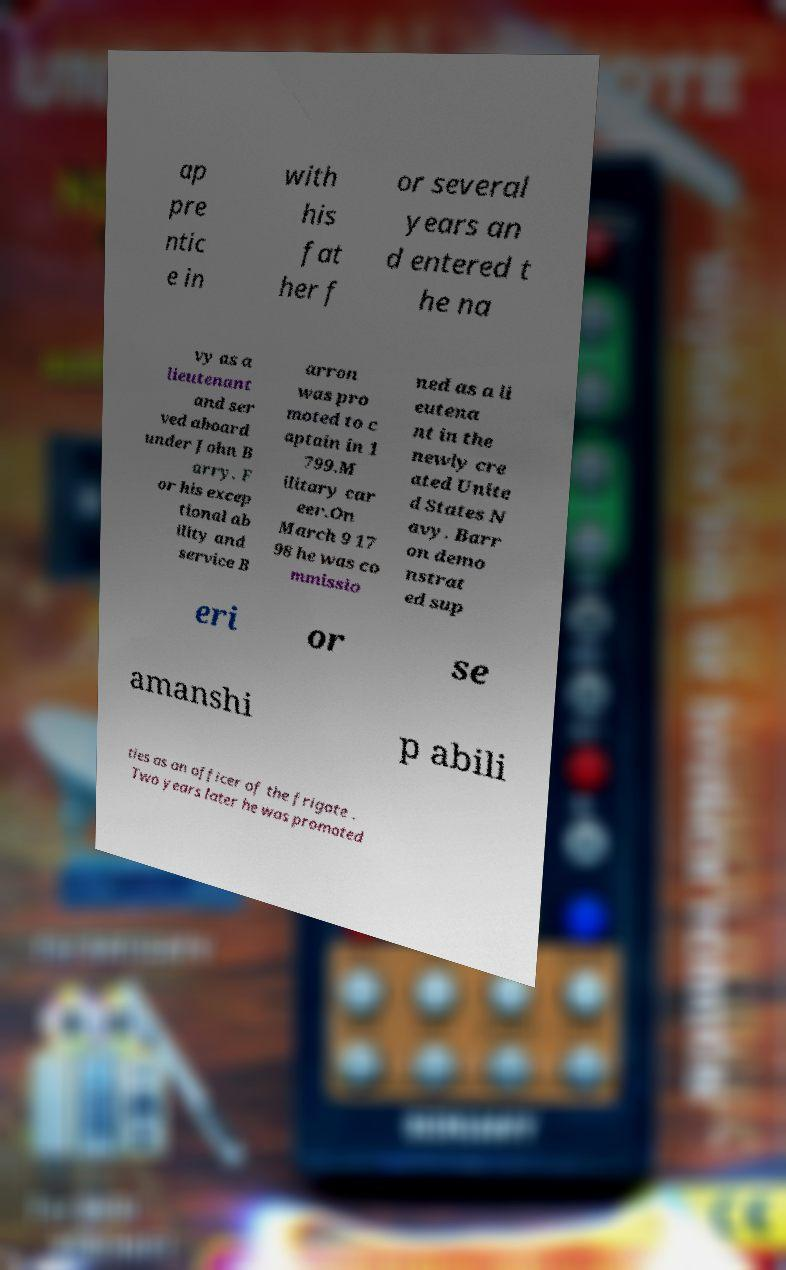There's text embedded in this image that I need extracted. Can you transcribe it verbatim? ap pre ntic e in with his fat her f or several years an d entered t he na vy as a lieutenant and ser ved aboard under John B arry. F or his excep tional ab ility and service B arron was pro moted to c aptain in 1 799.M ilitary car eer.On March 9 17 98 he was co mmissio ned as a li eutena nt in the newly cre ated Unite d States N avy. Barr on demo nstrat ed sup eri or se amanshi p abili ties as an officer of the frigate . Two years later he was promoted 